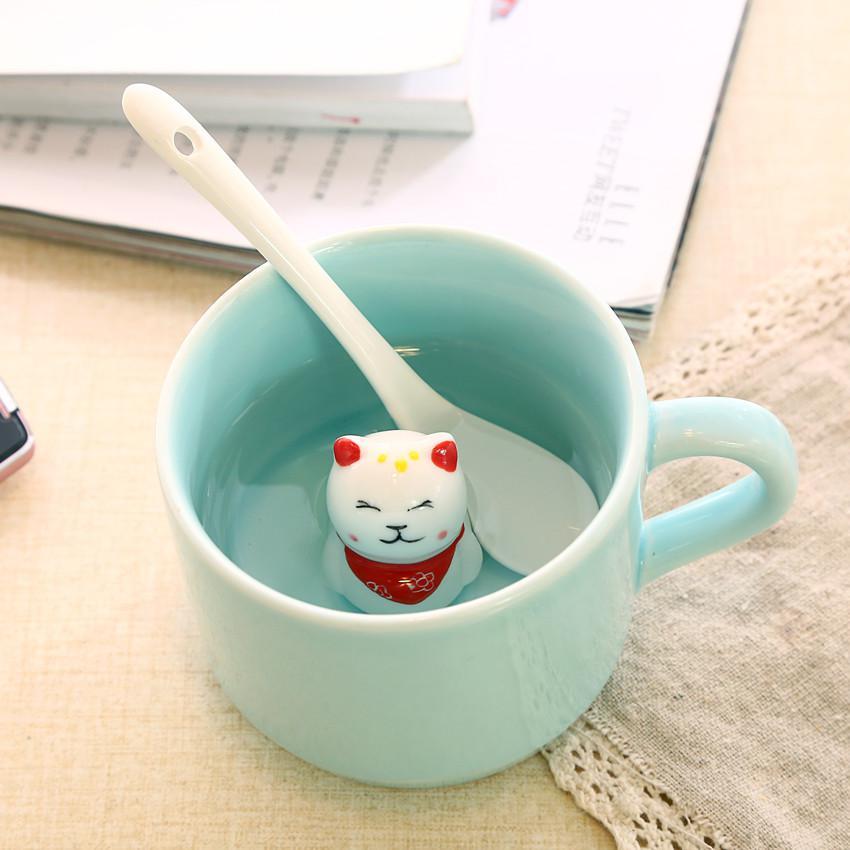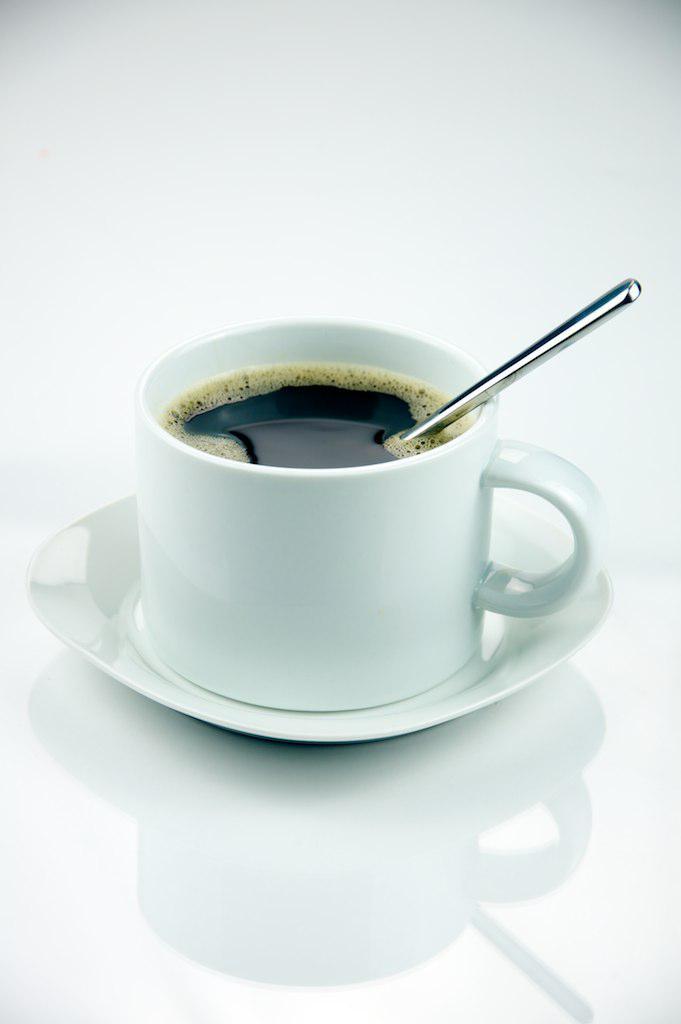The first image is the image on the left, the second image is the image on the right. Evaluate the accuracy of this statement regarding the images: "There is at least one orange spoon in the image on the right.". Is it true? Answer yes or no. No. 